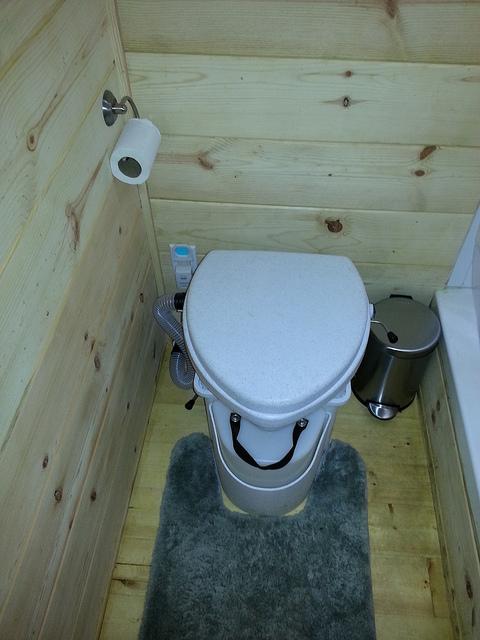What is the position of the toilet seat lid?
Write a very short answer. Down. Is the wall made of wood?
Give a very brief answer. Yes. Does this room look rustic?
Write a very short answer. Yes. 